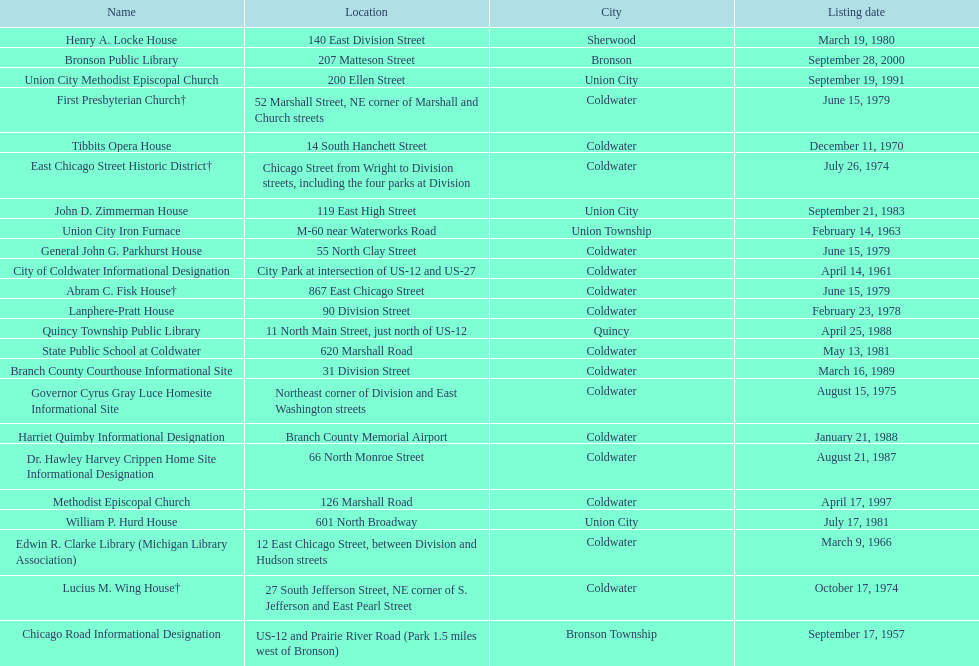How many historic sites were listed before 1965? 3. 